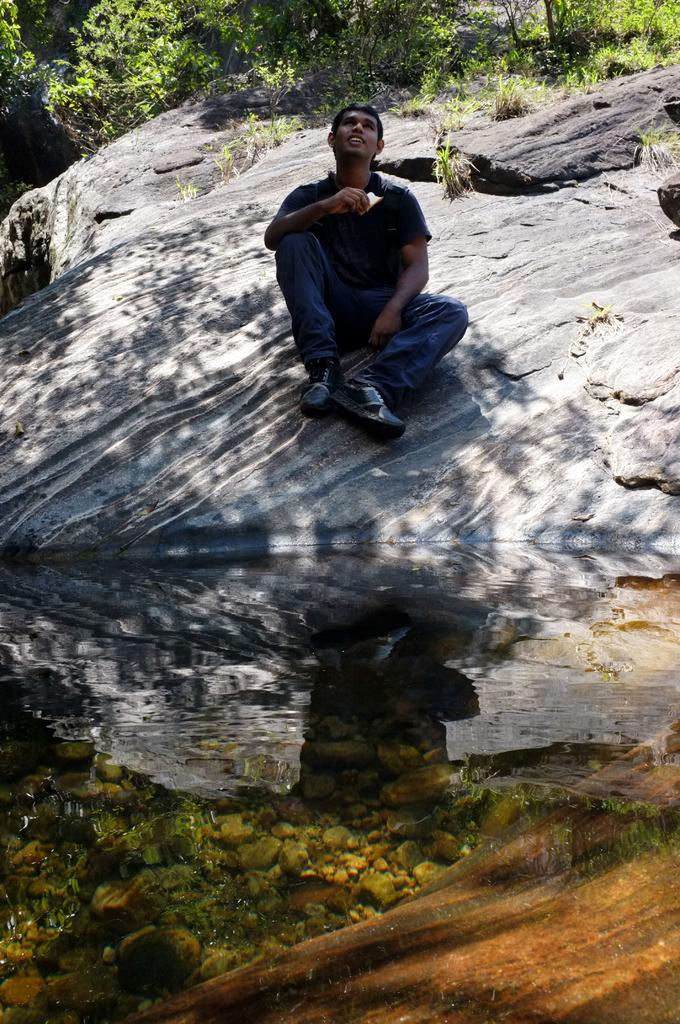What is the person in the image doing? There is a person sitting in the image. What can be seen in the background of the image? There are trees in the background of the image. What is the color of the trees in the image? The trees are green in color. What type of glove is the person wearing in the image? There is no glove visible in the image; the person is simply sitting. What sound does the alarm make in the image? There is no alarm present in the image. 